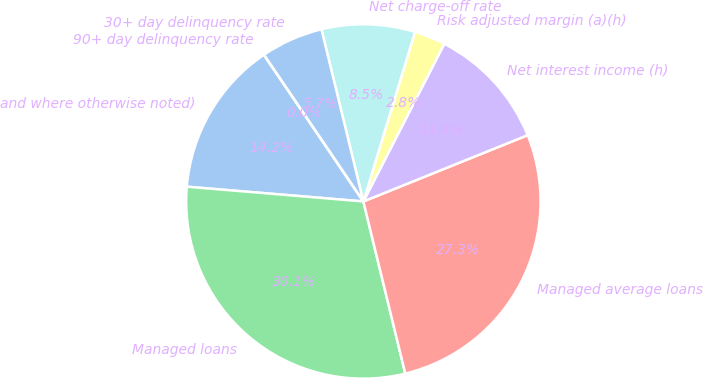Convert chart to OTSL. <chart><loc_0><loc_0><loc_500><loc_500><pie_chart><fcel>and where otherwise noted)<fcel>Managed loans<fcel>Managed average loans<fcel>Net interest income (h)<fcel>Risk adjusted margin (a)(h)<fcel>Net charge-off rate<fcel>30+ day delinquency rate<fcel>90+ day delinquency rate<nl><fcel>14.19%<fcel>30.13%<fcel>27.3%<fcel>11.35%<fcel>2.84%<fcel>8.51%<fcel>5.68%<fcel>0.0%<nl></chart> 